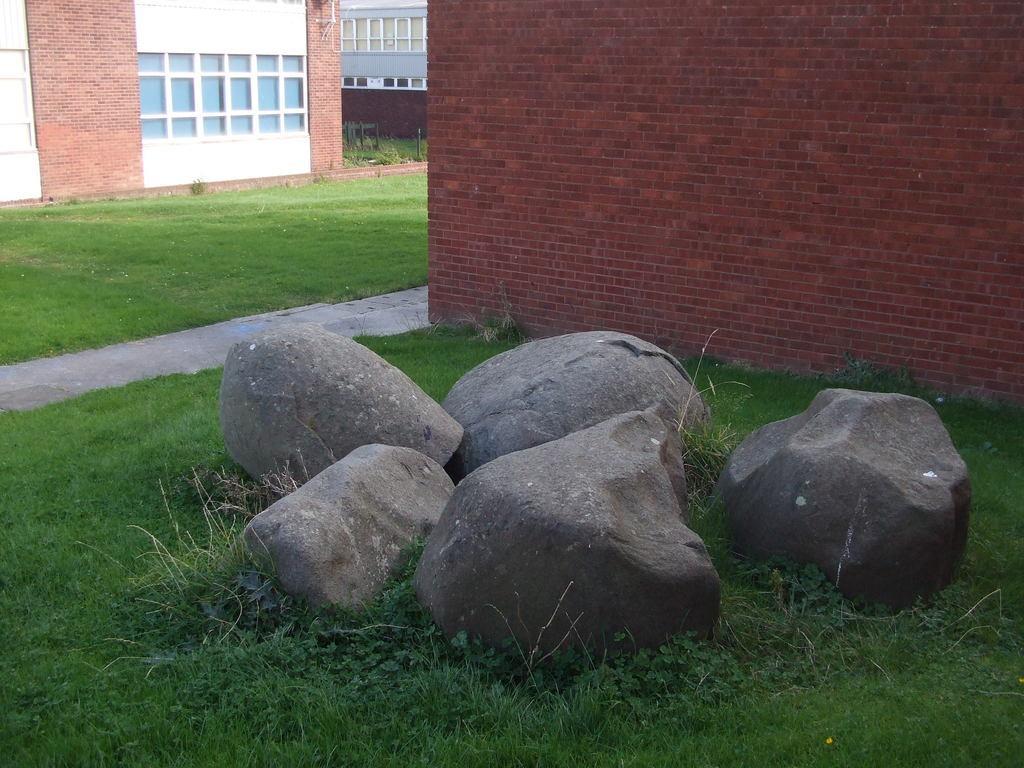Could you give a brief overview of what you see in this image? On the ground there is grass. Also there are stones. On the right side there is a brick wall. On the left side there are buildings with windows. 